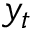<formula> <loc_0><loc_0><loc_500><loc_500>y _ { t }</formula> 